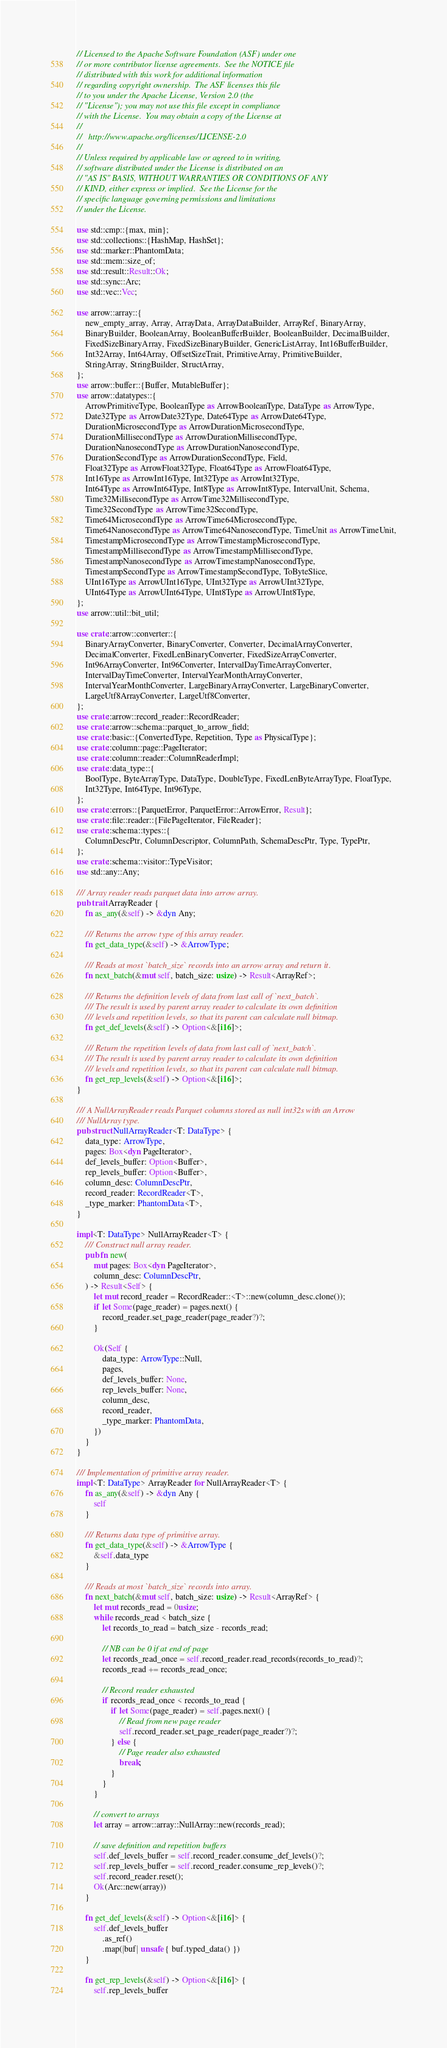<code> <loc_0><loc_0><loc_500><loc_500><_Rust_>// Licensed to the Apache Software Foundation (ASF) under one
// or more contributor license agreements.  See the NOTICE file
// distributed with this work for additional information
// regarding copyright ownership.  The ASF licenses this file
// to you under the Apache License, Version 2.0 (the
// "License"); you may not use this file except in compliance
// with the License.  You may obtain a copy of the License at
//
//   http://www.apache.org/licenses/LICENSE-2.0
//
// Unless required by applicable law or agreed to in writing,
// software distributed under the License is distributed on an
// "AS IS" BASIS, WITHOUT WARRANTIES OR CONDITIONS OF ANY
// KIND, either express or implied.  See the License for the
// specific language governing permissions and limitations
// under the License.

use std::cmp::{max, min};
use std::collections::{HashMap, HashSet};
use std::marker::PhantomData;
use std::mem::size_of;
use std::result::Result::Ok;
use std::sync::Arc;
use std::vec::Vec;

use arrow::array::{
    new_empty_array, Array, ArrayData, ArrayDataBuilder, ArrayRef, BinaryArray,
    BinaryBuilder, BooleanArray, BooleanBufferBuilder, BooleanBuilder, DecimalBuilder,
    FixedSizeBinaryArray, FixedSizeBinaryBuilder, GenericListArray, Int16BufferBuilder,
    Int32Array, Int64Array, OffsetSizeTrait, PrimitiveArray, PrimitiveBuilder,
    StringArray, StringBuilder, StructArray,
};
use arrow::buffer::{Buffer, MutableBuffer};
use arrow::datatypes::{
    ArrowPrimitiveType, BooleanType as ArrowBooleanType, DataType as ArrowType,
    Date32Type as ArrowDate32Type, Date64Type as ArrowDate64Type,
    DurationMicrosecondType as ArrowDurationMicrosecondType,
    DurationMillisecondType as ArrowDurationMillisecondType,
    DurationNanosecondType as ArrowDurationNanosecondType,
    DurationSecondType as ArrowDurationSecondType, Field,
    Float32Type as ArrowFloat32Type, Float64Type as ArrowFloat64Type,
    Int16Type as ArrowInt16Type, Int32Type as ArrowInt32Type,
    Int64Type as ArrowInt64Type, Int8Type as ArrowInt8Type, IntervalUnit, Schema,
    Time32MillisecondType as ArrowTime32MillisecondType,
    Time32SecondType as ArrowTime32SecondType,
    Time64MicrosecondType as ArrowTime64MicrosecondType,
    Time64NanosecondType as ArrowTime64NanosecondType, TimeUnit as ArrowTimeUnit,
    TimestampMicrosecondType as ArrowTimestampMicrosecondType,
    TimestampMillisecondType as ArrowTimestampMillisecondType,
    TimestampNanosecondType as ArrowTimestampNanosecondType,
    TimestampSecondType as ArrowTimestampSecondType, ToByteSlice,
    UInt16Type as ArrowUInt16Type, UInt32Type as ArrowUInt32Type,
    UInt64Type as ArrowUInt64Type, UInt8Type as ArrowUInt8Type,
};
use arrow::util::bit_util;

use crate::arrow::converter::{
    BinaryArrayConverter, BinaryConverter, Converter, DecimalArrayConverter,
    DecimalConverter, FixedLenBinaryConverter, FixedSizeArrayConverter,
    Int96ArrayConverter, Int96Converter, IntervalDayTimeArrayConverter,
    IntervalDayTimeConverter, IntervalYearMonthArrayConverter,
    IntervalYearMonthConverter, LargeBinaryArrayConverter, LargeBinaryConverter,
    LargeUtf8ArrayConverter, LargeUtf8Converter,
};
use crate::arrow::record_reader::RecordReader;
use crate::arrow::schema::parquet_to_arrow_field;
use crate::basic::{ConvertedType, Repetition, Type as PhysicalType};
use crate::column::page::PageIterator;
use crate::column::reader::ColumnReaderImpl;
use crate::data_type::{
    BoolType, ByteArrayType, DataType, DoubleType, FixedLenByteArrayType, FloatType,
    Int32Type, Int64Type, Int96Type,
};
use crate::errors::{ParquetError, ParquetError::ArrowError, Result};
use crate::file::reader::{FilePageIterator, FileReader};
use crate::schema::types::{
    ColumnDescPtr, ColumnDescriptor, ColumnPath, SchemaDescPtr, Type, TypePtr,
};
use crate::schema::visitor::TypeVisitor;
use std::any::Any;

/// Array reader reads parquet data into arrow array.
pub trait ArrayReader {
    fn as_any(&self) -> &dyn Any;

    /// Returns the arrow type of this array reader.
    fn get_data_type(&self) -> &ArrowType;

    /// Reads at most `batch_size` records into an arrow array and return it.
    fn next_batch(&mut self, batch_size: usize) -> Result<ArrayRef>;

    /// Returns the definition levels of data from last call of `next_batch`.
    /// The result is used by parent array reader to calculate its own definition
    /// levels and repetition levels, so that its parent can calculate null bitmap.
    fn get_def_levels(&self) -> Option<&[i16]>;

    /// Return the repetition levels of data from last call of `next_batch`.
    /// The result is used by parent array reader to calculate its own definition
    /// levels and repetition levels, so that its parent can calculate null bitmap.
    fn get_rep_levels(&self) -> Option<&[i16]>;
}

/// A NullArrayReader reads Parquet columns stored as null int32s with an Arrow
/// NullArray type.
pub struct NullArrayReader<T: DataType> {
    data_type: ArrowType,
    pages: Box<dyn PageIterator>,
    def_levels_buffer: Option<Buffer>,
    rep_levels_buffer: Option<Buffer>,
    column_desc: ColumnDescPtr,
    record_reader: RecordReader<T>,
    _type_marker: PhantomData<T>,
}

impl<T: DataType> NullArrayReader<T> {
    /// Construct null array reader.
    pub fn new(
        mut pages: Box<dyn PageIterator>,
        column_desc: ColumnDescPtr,
    ) -> Result<Self> {
        let mut record_reader = RecordReader::<T>::new(column_desc.clone());
        if let Some(page_reader) = pages.next() {
            record_reader.set_page_reader(page_reader?)?;
        }

        Ok(Self {
            data_type: ArrowType::Null,
            pages,
            def_levels_buffer: None,
            rep_levels_buffer: None,
            column_desc,
            record_reader,
            _type_marker: PhantomData,
        })
    }
}

/// Implementation of primitive array reader.
impl<T: DataType> ArrayReader for NullArrayReader<T> {
    fn as_any(&self) -> &dyn Any {
        self
    }

    /// Returns data type of primitive array.
    fn get_data_type(&self) -> &ArrowType {
        &self.data_type
    }

    /// Reads at most `batch_size` records into array.
    fn next_batch(&mut self, batch_size: usize) -> Result<ArrayRef> {
        let mut records_read = 0usize;
        while records_read < batch_size {
            let records_to_read = batch_size - records_read;

            // NB can be 0 if at end of page
            let records_read_once = self.record_reader.read_records(records_to_read)?;
            records_read += records_read_once;

            // Record reader exhausted
            if records_read_once < records_to_read {
                if let Some(page_reader) = self.pages.next() {
                    // Read from new page reader
                    self.record_reader.set_page_reader(page_reader?)?;
                } else {
                    // Page reader also exhausted
                    break;
                }
            }
        }

        // convert to arrays
        let array = arrow::array::NullArray::new(records_read);

        // save definition and repetition buffers
        self.def_levels_buffer = self.record_reader.consume_def_levels()?;
        self.rep_levels_buffer = self.record_reader.consume_rep_levels()?;
        self.record_reader.reset();
        Ok(Arc::new(array))
    }

    fn get_def_levels(&self) -> Option<&[i16]> {
        self.def_levels_buffer
            .as_ref()
            .map(|buf| unsafe { buf.typed_data() })
    }

    fn get_rep_levels(&self) -> Option<&[i16]> {
        self.rep_levels_buffer</code> 